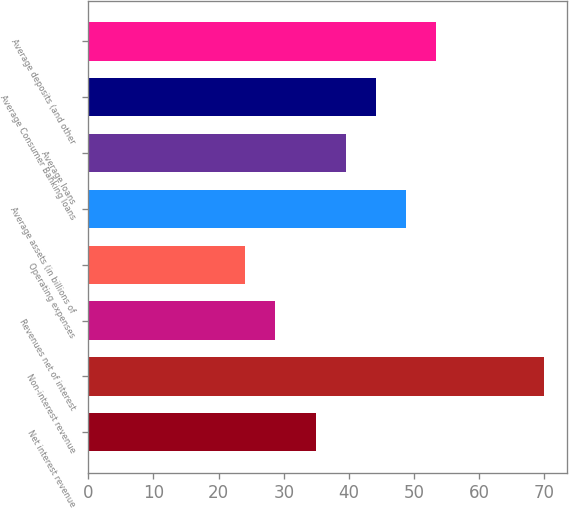Convert chart to OTSL. <chart><loc_0><loc_0><loc_500><loc_500><bar_chart><fcel>Net interest revenue<fcel>Non-interest revenue<fcel>Revenues net of interest<fcel>Operating expenses<fcel>Average assets (in billions of<fcel>Average loans<fcel>Average Consumer Banking loans<fcel>Average deposits (and other<nl><fcel>35<fcel>70<fcel>28.6<fcel>24<fcel>48.8<fcel>39.6<fcel>44.2<fcel>53.4<nl></chart> 